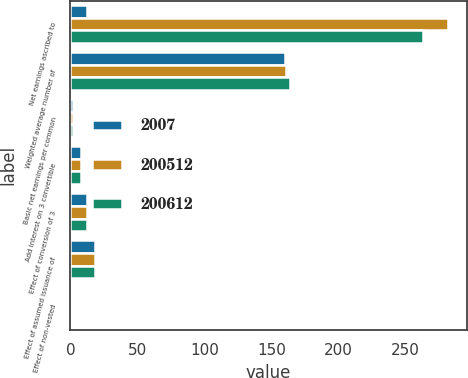<chart> <loc_0><loc_0><loc_500><loc_500><stacked_bar_chart><ecel><fcel>Net earnings ascribed to<fcel>Weighted average number of<fcel>Basic net earnings per common<fcel>Add Interest on 3 convertible<fcel>Effect of conversion of 3<fcel>Effect of assumed issuance of<fcel>Effect of non-vested<nl><fcel>2007<fcel>12.5<fcel>160<fcel>2.21<fcel>7.9<fcel>12.5<fcel>18<fcel>0.8<nl><fcel>200512<fcel>281.9<fcel>160.8<fcel>1.7<fcel>7.8<fcel>12.4<fcel>18<fcel>0.8<nl><fcel>200612<fcel>263.6<fcel>163.9<fcel>1.56<fcel>7.8<fcel>12.3<fcel>18<fcel>0.9<nl></chart> 